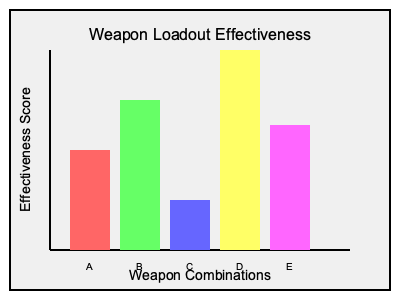Based on the graph showing weapon loadout effectiveness for different combinations, which weapon combination (A, B, C, D, or E) should be prioritized for the team's loadout strategy in the upcoming eSport tournament? To determine the optimal weapon loadout for the team's strategy, we need to analyze the effectiveness scores of each combination shown in the graph:

1. Combination A (Red): Effectiveness score of approximately 100
2. Combination B (Green): Effectiveness score of approximately 150
3. Combination C (Blue): Effectiveness score of approximately 50
4. Combination D (Yellow): Effectiveness score of approximately 200
5. Combination E (Pink): Effectiveness score of approximately 125

Step 1: Identify the highest effectiveness score.
The highest bar in the graph represents the most effective weapon combination.

Step 2: Match the highest bar to its corresponding label.
The tallest bar is yellow, which corresponds to combination D.

Step 3: Consider strategic implications.
As a team manager, prioritizing the most effective weapon loadout can give your team a competitive advantage in the tournament.

Step 4: Make a decision based on the data.
Given that combination D has the highest effectiveness score of approximately 200, it should be prioritized for the team's loadout strategy.
Answer: Combination D 